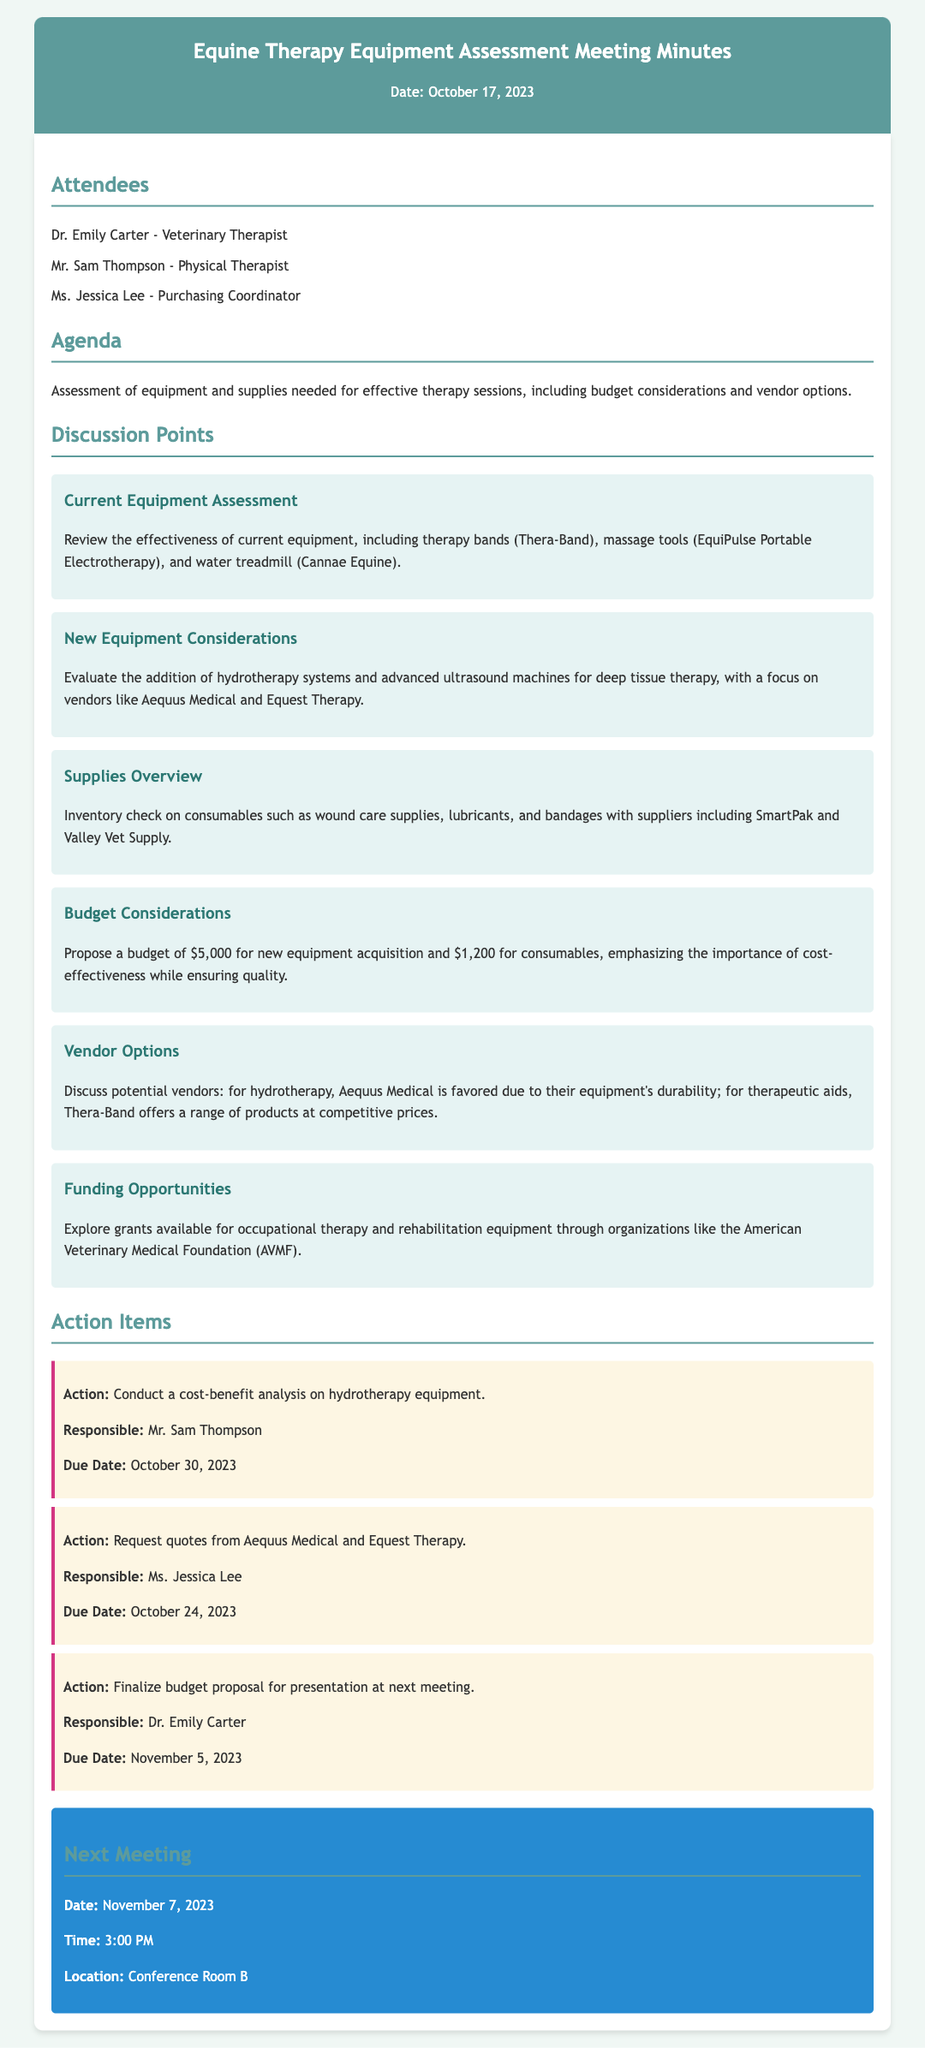What is the date of the meeting? The date of the meeting is stated in the header section of the document.
Answer: October 17, 2023 Who is responsible for conducting the cost-benefit analysis on hydrotherapy equipment? The document lists the responsibilities associated with each action item, showing the person in charge.
Answer: Mr. Sam Thompson What is the proposed budget for new equipment acquisition? The budget considerations section specifies the amount allocated for new equipment.
Answer: $5,000 Which vendor is favored for hydrotherapy equipment? The vendor options section discusses preferred vendors for different equipment types.
Answer: Aequus Medical When is the next meeting scheduled? The next meeting details are provided at the end of the document.
Answer: November 7, 2023 What type of supplies was mentioned in the overview? The supplies overview lists specific consumables that need to be inventoried.
Answer: Wound care supplies, lubricants, and bandages What is the due date for requesting quotes from Aequus Medical and Equest Therapy? The due date is provided alongside the action item related to requesting quotes.
Answer: October 24, 2023 What is the budget for consumables? The budget considerations section outlines the budget allocations for various categories.
Answer: $1,200 Who is the purchasing coordinator attending the meeting? The attendees section names individuals present at the meeting and their roles.
Answer: Ms. Jessica Lee 